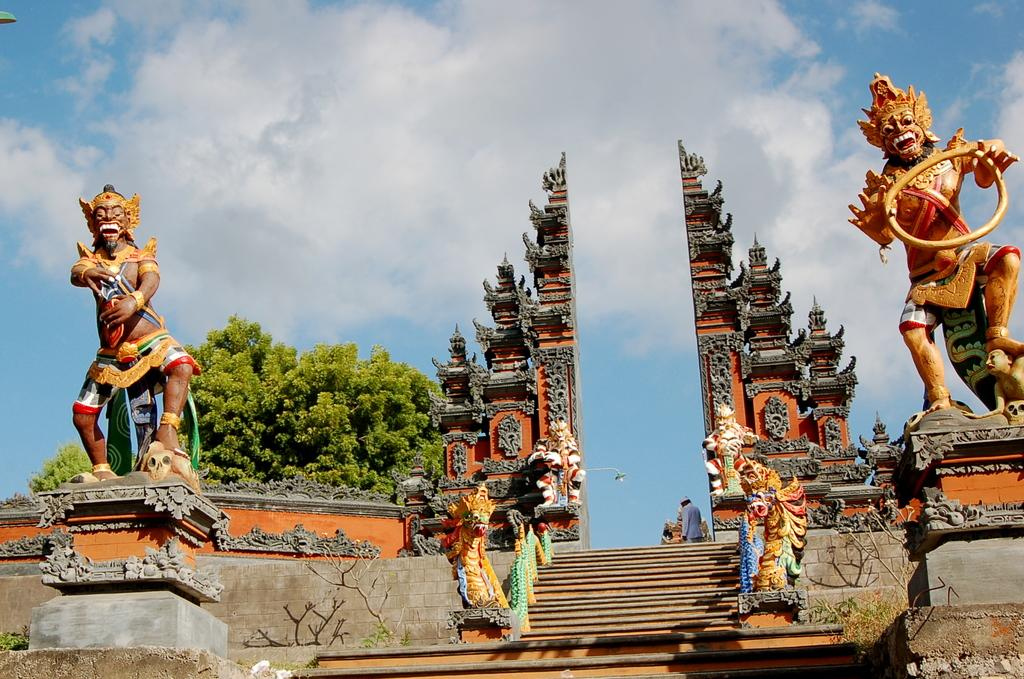What type of artwork is present in the image? There are sculptures in the image. What other elements can be seen in the image besides the sculptures? There are trees and stairs visible in the image. Is there any indication of a person's presence in the image? Yes, there is a person in the image. What can be seen in the background of the image? The sky is visible in the background of the image. How many giants are holding the cannon in the image? There are no giants or cannons present in the image. What type of face can be seen on the sculptures in the image? The provided facts do not mention any faces on the sculptures, so we cannot answer this question. 